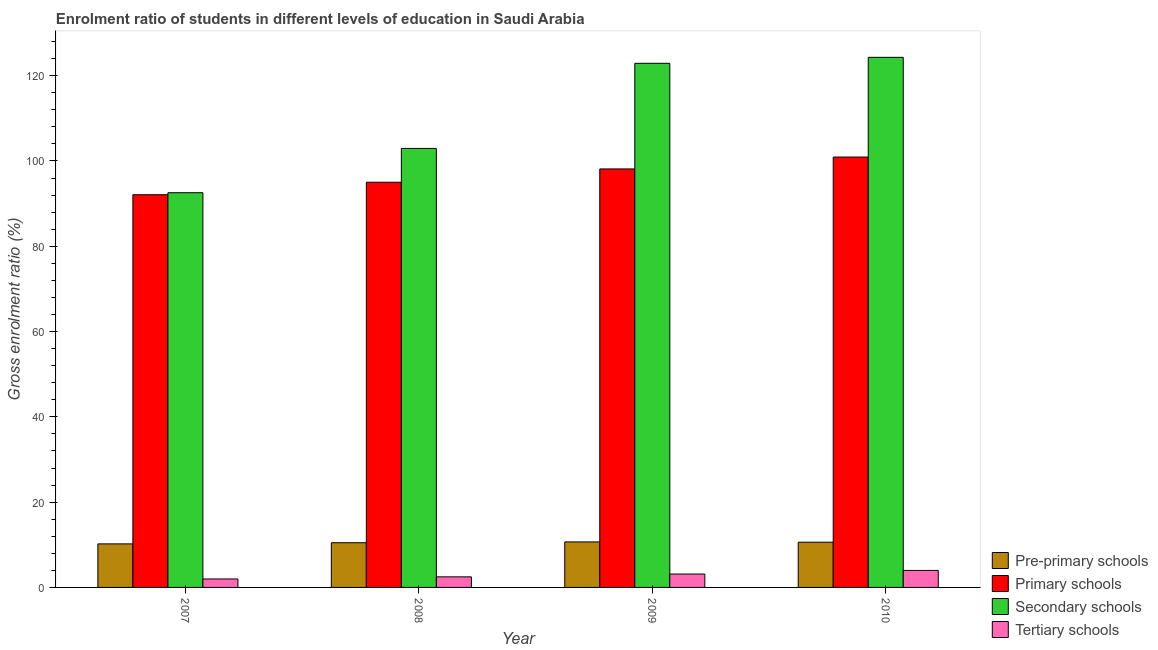How many bars are there on the 1st tick from the left?
Your answer should be very brief. 4. How many bars are there on the 1st tick from the right?
Your response must be concise. 4. What is the label of the 3rd group of bars from the left?
Offer a very short reply. 2009. What is the gross enrolment ratio in primary schools in 2009?
Provide a short and direct response. 98.13. Across all years, what is the maximum gross enrolment ratio in pre-primary schools?
Keep it short and to the point. 10.67. Across all years, what is the minimum gross enrolment ratio in pre-primary schools?
Keep it short and to the point. 10.21. What is the total gross enrolment ratio in secondary schools in the graph?
Your answer should be very brief. 442.69. What is the difference between the gross enrolment ratio in primary schools in 2009 and that in 2010?
Make the answer very short. -2.78. What is the difference between the gross enrolment ratio in pre-primary schools in 2008 and the gross enrolment ratio in primary schools in 2007?
Offer a terse response. 0.27. What is the average gross enrolment ratio in tertiary schools per year?
Keep it short and to the point. 2.9. What is the ratio of the gross enrolment ratio in pre-primary schools in 2007 to that in 2008?
Your answer should be very brief. 0.97. Is the gross enrolment ratio in secondary schools in 2007 less than that in 2010?
Offer a very short reply. Yes. Is the difference between the gross enrolment ratio in primary schools in 2007 and 2009 greater than the difference between the gross enrolment ratio in pre-primary schools in 2007 and 2009?
Your answer should be very brief. No. What is the difference between the highest and the second highest gross enrolment ratio in tertiary schools?
Your answer should be compact. 0.86. What is the difference between the highest and the lowest gross enrolment ratio in tertiary schools?
Your answer should be compact. 2.01. In how many years, is the gross enrolment ratio in tertiary schools greater than the average gross enrolment ratio in tertiary schools taken over all years?
Your answer should be very brief. 2. Is the sum of the gross enrolment ratio in primary schools in 2009 and 2010 greater than the maximum gross enrolment ratio in pre-primary schools across all years?
Make the answer very short. Yes. Is it the case that in every year, the sum of the gross enrolment ratio in primary schools and gross enrolment ratio in secondary schools is greater than the sum of gross enrolment ratio in tertiary schools and gross enrolment ratio in pre-primary schools?
Ensure brevity in your answer.  No. What does the 1st bar from the left in 2007 represents?
Your response must be concise. Pre-primary schools. What does the 1st bar from the right in 2008 represents?
Your answer should be compact. Tertiary schools. Are all the bars in the graph horizontal?
Offer a very short reply. No. What is the difference between two consecutive major ticks on the Y-axis?
Keep it short and to the point. 20. Are the values on the major ticks of Y-axis written in scientific E-notation?
Make the answer very short. No. Does the graph contain grids?
Keep it short and to the point. No. How many legend labels are there?
Your answer should be compact. 4. What is the title of the graph?
Provide a short and direct response. Enrolment ratio of students in different levels of education in Saudi Arabia. What is the label or title of the X-axis?
Provide a short and direct response. Year. What is the label or title of the Y-axis?
Give a very brief answer. Gross enrolment ratio (%). What is the Gross enrolment ratio (%) in Pre-primary schools in 2007?
Your answer should be compact. 10.21. What is the Gross enrolment ratio (%) of Primary schools in 2007?
Offer a terse response. 92.08. What is the Gross enrolment ratio (%) in Secondary schools in 2007?
Keep it short and to the point. 92.55. What is the Gross enrolment ratio (%) of Tertiary schools in 2007?
Give a very brief answer. 1.98. What is the Gross enrolment ratio (%) in Pre-primary schools in 2008?
Offer a terse response. 10.48. What is the Gross enrolment ratio (%) of Primary schools in 2008?
Provide a succinct answer. 95.01. What is the Gross enrolment ratio (%) of Secondary schools in 2008?
Keep it short and to the point. 102.94. What is the Gross enrolment ratio (%) of Tertiary schools in 2008?
Keep it short and to the point. 2.48. What is the Gross enrolment ratio (%) in Pre-primary schools in 2009?
Your answer should be very brief. 10.67. What is the Gross enrolment ratio (%) of Primary schools in 2009?
Give a very brief answer. 98.13. What is the Gross enrolment ratio (%) in Secondary schools in 2009?
Offer a very short reply. 122.9. What is the Gross enrolment ratio (%) of Tertiary schools in 2009?
Offer a very short reply. 3.13. What is the Gross enrolment ratio (%) in Pre-primary schools in 2010?
Offer a terse response. 10.61. What is the Gross enrolment ratio (%) in Primary schools in 2010?
Your answer should be very brief. 100.91. What is the Gross enrolment ratio (%) in Secondary schools in 2010?
Your answer should be very brief. 124.3. What is the Gross enrolment ratio (%) in Tertiary schools in 2010?
Your response must be concise. 3.99. Across all years, what is the maximum Gross enrolment ratio (%) of Pre-primary schools?
Your response must be concise. 10.67. Across all years, what is the maximum Gross enrolment ratio (%) in Primary schools?
Ensure brevity in your answer.  100.91. Across all years, what is the maximum Gross enrolment ratio (%) of Secondary schools?
Provide a succinct answer. 124.3. Across all years, what is the maximum Gross enrolment ratio (%) of Tertiary schools?
Give a very brief answer. 3.99. Across all years, what is the minimum Gross enrolment ratio (%) of Pre-primary schools?
Your response must be concise. 10.21. Across all years, what is the minimum Gross enrolment ratio (%) in Primary schools?
Keep it short and to the point. 92.08. Across all years, what is the minimum Gross enrolment ratio (%) in Secondary schools?
Make the answer very short. 92.55. Across all years, what is the minimum Gross enrolment ratio (%) in Tertiary schools?
Make the answer very short. 1.98. What is the total Gross enrolment ratio (%) in Pre-primary schools in the graph?
Provide a short and direct response. 41.97. What is the total Gross enrolment ratio (%) of Primary schools in the graph?
Give a very brief answer. 386.13. What is the total Gross enrolment ratio (%) of Secondary schools in the graph?
Make the answer very short. 442.69. What is the total Gross enrolment ratio (%) of Tertiary schools in the graph?
Give a very brief answer. 11.59. What is the difference between the Gross enrolment ratio (%) in Pre-primary schools in 2007 and that in 2008?
Give a very brief answer. -0.27. What is the difference between the Gross enrolment ratio (%) of Primary schools in 2007 and that in 2008?
Your response must be concise. -2.93. What is the difference between the Gross enrolment ratio (%) in Secondary schools in 2007 and that in 2008?
Your response must be concise. -10.39. What is the difference between the Gross enrolment ratio (%) in Tertiary schools in 2007 and that in 2008?
Your response must be concise. -0.49. What is the difference between the Gross enrolment ratio (%) of Pre-primary schools in 2007 and that in 2009?
Provide a succinct answer. -0.46. What is the difference between the Gross enrolment ratio (%) of Primary schools in 2007 and that in 2009?
Offer a terse response. -6.05. What is the difference between the Gross enrolment ratio (%) in Secondary schools in 2007 and that in 2009?
Make the answer very short. -30.35. What is the difference between the Gross enrolment ratio (%) in Tertiary schools in 2007 and that in 2009?
Your answer should be compact. -1.15. What is the difference between the Gross enrolment ratio (%) in Pre-primary schools in 2007 and that in 2010?
Keep it short and to the point. -0.4. What is the difference between the Gross enrolment ratio (%) of Primary schools in 2007 and that in 2010?
Offer a very short reply. -8.83. What is the difference between the Gross enrolment ratio (%) in Secondary schools in 2007 and that in 2010?
Offer a terse response. -31.75. What is the difference between the Gross enrolment ratio (%) in Tertiary schools in 2007 and that in 2010?
Make the answer very short. -2.01. What is the difference between the Gross enrolment ratio (%) in Pre-primary schools in 2008 and that in 2009?
Your answer should be very brief. -0.19. What is the difference between the Gross enrolment ratio (%) in Primary schools in 2008 and that in 2009?
Your answer should be compact. -3.12. What is the difference between the Gross enrolment ratio (%) in Secondary schools in 2008 and that in 2009?
Your answer should be compact. -19.96. What is the difference between the Gross enrolment ratio (%) in Tertiary schools in 2008 and that in 2009?
Offer a very short reply. -0.66. What is the difference between the Gross enrolment ratio (%) of Pre-primary schools in 2008 and that in 2010?
Provide a succinct answer. -0.12. What is the difference between the Gross enrolment ratio (%) in Primary schools in 2008 and that in 2010?
Make the answer very short. -5.91. What is the difference between the Gross enrolment ratio (%) of Secondary schools in 2008 and that in 2010?
Your answer should be compact. -21.36. What is the difference between the Gross enrolment ratio (%) of Tertiary schools in 2008 and that in 2010?
Your answer should be compact. -1.51. What is the difference between the Gross enrolment ratio (%) of Pre-primary schools in 2009 and that in 2010?
Offer a very short reply. 0.07. What is the difference between the Gross enrolment ratio (%) of Primary schools in 2009 and that in 2010?
Keep it short and to the point. -2.78. What is the difference between the Gross enrolment ratio (%) in Secondary schools in 2009 and that in 2010?
Make the answer very short. -1.4. What is the difference between the Gross enrolment ratio (%) in Tertiary schools in 2009 and that in 2010?
Make the answer very short. -0.86. What is the difference between the Gross enrolment ratio (%) of Pre-primary schools in 2007 and the Gross enrolment ratio (%) of Primary schools in 2008?
Provide a succinct answer. -84.8. What is the difference between the Gross enrolment ratio (%) of Pre-primary schools in 2007 and the Gross enrolment ratio (%) of Secondary schools in 2008?
Offer a terse response. -92.73. What is the difference between the Gross enrolment ratio (%) of Pre-primary schools in 2007 and the Gross enrolment ratio (%) of Tertiary schools in 2008?
Keep it short and to the point. 7.73. What is the difference between the Gross enrolment ratio (%) of Primary schools in 2007 and the Gross enrolment ratio (%) of Secondary schools in 2008?
Provide a short and direct response. -10.86. What is the difference between the Gross enrolment ratio (%) in Primary schools in 2007 and the Gross enrolment ratio (%) in Tertiary schools in 2008?
Your answer should be compact. 89.6. What is the difference between the Gross enrolment ratio (%) of Secondary schools in 2007 and the Gross enrolment ratio (%) of Tertiary schools in 2008?
Make the answer very short. 90.07. What is the difference between the Gross enrolment ratio (%) in Pre-primary schools in 2007 and the Gross enrolment ratio (%) in Primary schools in 2009?
Give a very brief answer. -87.92. What is the difference between the Gross enrolment ratio (%) of Pre-primary schools in 2007 and the Gross enrolment ratio (%) of Secondary schools in 2009?
Provide a short and direct response. -112.69. What is the difference between the Gross enrolment ratio (%) of Pre-primary schools in 2007 and the Gross enrolment ratio (%) of Tertiary schools in 2009?
Provide a succinct answer. 7.08. What is the difference between the Gross enrolment ratio (%) in Primary schools in 2007 and the Gross enrolment ratio (%) in Secondary schools in 2009?
Make the answer very short. -30.82. What is the difference between the Gross enrolment ratio (%) of Primary schools in 2007 and the Gross enrolment ratio (%) of Tertiary schools in 2009?
Give a very brief answer. 88.95. What is the difference between the Gross enrolment ratio (%) in Secondary schools in 2007 and the Gross enrolment ratio (%) in Tertiary schools in 2009?
Keep it short and to the point. 89.42. What is the difference between the Gross enrolment ratio (%) in Pre-primary schools in 2007 and the Gross enrolment ratio (%) in Primary schools in 2010?
Ensure brevity in your answer.  -90.71. What is the difference between the Gross enrolment ratio (%) in Pre-primary schools in 2007 and the Gross enrolment ratio (%) in Secondary schools in 2010?
Make the answer very short. -114.09. What is the difference between the Gross enrolment ratio (%) in Pre-primary schools in 2007 and the Gross enrolment ratio (%) in Tertiary schools in 2010?
Ensure brevity in your answer.  6.22. What is the difference between the Gross enrolment ratio (%) in Primary schools in 2007 and the Gross enrolment ratio (%) in Secondary schools in 2010?
Your answer should be very brief. -32.22. What is the difference between the Gross enrolment ratio (%) in Primary schools in 2007 and the Gross enrolment ratio (%) in Tertiary schools in 2010?
Ensure brevity in your answer.  88.09. What is the difference between the Gross enrolment ratio (%) of Secondary schools in 2007 and the Gross enrolment ratio (%) of Tertiary schools in 2010?
Provide a succinct answer. 88.56. What is the difference between the Gross enrolment ratio (%) in Pre-primary schools in 2008 and the Gross enrolment ratio (%) in Primary schools in 2009?
Provide a short and direct response. -87.65. What is the difference between the Gross enrolment ratio (%) in Pre-primary schools in 2008 and the Gross enrolment ratio (%) in Secondary schools in 2009?
Your response must be concise. -112.42. What is the difference between the Gross enrolment ratio (%) in Pre-primary schools in 2008 and the Gross enrolment ratio (%) in Tertiary schools in 2009?
Offer a terse response. 7.35. What is the difference between the Gross enrolment ratio (%) in Primary schools in 2008 and the Gross enrolment ratio (%) in Secondary schools in 2009?
Ensure brevity in your answer.  -27.89. What is the difference between the Gross enrolment ratio (%) in Primary schools in 2008 and the Gross enrolment ratio (%) in Tertiary schools in 2009?
Your response must be concise. 91.87. What is the difference between the Gross enrolment ratio (%) of Secondary schools in 2008 and the Gross enrolment ratio (%) of Tertiary schools in 2009?
Make the answer very short. 99.81. What is the difference between the Gross enrolment ratio (%) in Pre-primary schools in 2008 and the Gross enrolment ratio (%) in Primary schools in 2010?
Provide a short and direct response. -90.43. What is the difference between the Gross enrolment ratio (%) in Pre-primary schools in 2008 and the Gross enrolment ratio (%) in Secondary schools in 2010?
Your answer should be very brief. -113.82. What is the difference between the Gross enrolment ratio (%) in Pre-primary schools in 2008 and the Gross enrolment ratio (%) in Tertiary schools in 2010?
Your response must be concise. 6.49. What is the difference between the Gross enrolment ratio (%) in Primary schools in 2008 and the Gross enrolment ratio (%) in Secondary schools in 2010?
Offer a very short reply. -29.29. What is the difference between the Gross enrolment ratio (%) of Primary schools in 2008 and the Gross enrolment ratio (%) of Tertiary schools in 2010?
Your answer should be very brief. 91.02. What is the difference between the Gross enrolment ratio (%) of Secondary schools in 2008 and the Gross enrolment ratio (%) of Tertiary schools in 2010?
Keep it short and to the point. 98.95. What is the difference between the Gross enrolment ratio (%) of Pre-primary schools in 2009 and the Gross enrolment ratio (%) of Primary schools in 2010?
Make the answer very short. -90.24. What is the difference between the Gross enrolment ratio (%) of Pre-primary schools in 2009 and the Gross enrolment ratio (%) of Secondary schools in 2010?
Make the answer very short. -113.63. What is the difference between the Gross enrolment ratio (%) of Pre-primary schools in 2009 and the Gross enrolment ratio (%) of Tertiary schools in 2010?
Keep it short and to the point. 6.68. What is the difference between the Gross enrolment ratio (%) in Primary schools in 2009 and the Gross enrolment ratio (%) in Secondary schools in 2010?
Offer a terse response. -26.17. What is the difference between the Gross enrolment ratio (%) in Primary schools in 2009 and the Gross enrolment ratio (%) in Tertiary schools in 2010?
Keep it short and to the point. 94.14. What is the difference between the Gross enrolment ratio (%) in Secondary schools in 2009 and the Gross enrolment ratio (%) in Tertiary schools in 2010?
Keep it short and to the point. 118.91. What is the average Gross enrolment ratio (%) in Pre-primary schools per year?
Offer a very short reply. 10.49. What is the average Gross enrolment ratio (%) in Primary schools per year?
Give a very brief answer. 96.53. What is the average Gross enrolment ratio (%) of Secondary schools per year?
Your answer should be very brief. 110.67. What is the average Gross enrolment ratio (%) in Tertiary schools per year?
Provide a succinct answer. 2.9. In the year 2007, what is the difference between the Gross enrolment ratio (%) in Pre-primary schools and Gross enrolment ratio (%) in Primary schools?
Your response must be concise. -81.87. In the year 2007, what is the difference between the Gross enrolment ratio (%) in Pre-primary schools and Gross enrolment ratio (%) in Secondary schools?
Offer a very short reply. -82.34. In the year 2007, what is the difference between the Gross enrolment ratio (%) of Pre-primary schools and Gross enrolment ratio (%) of Tertiary schools?
Your response must be concise. 8.23. In the year 2007, what is the difference between the Gross enrolment ratio (%) of Primary schools and Gross enrolment ratio (%) of Secondary schools?
Your answer should be compact. -0.47. In the year 2007, what is the difference between the Gross enrolment ratio (%) in Primary schools and Gross enrolment ratio (%) in Tertiary schools?
Your answer should be compact. 90.1. In the year 2007, what is the difference between the Gross enrolment ratio (%) in Secondary schools and Gross enrolment ratio (%) in Tertiary schools?
Your response must be concise. 90.57. In the year 2008, what is the difference between the Gross enrolment ratio (%) in Pre-primary schools and Gross enrolment ratio (%) in Primary schools?
Your answer should be very brief. -84.53. In the year 2008, what is the difference between the Gross enrolment ratio (%) of Pre-primary schools and Gross enrolment ratio (%) of Secondary schools?
Your answer should be very brief. -92.46. In the year 2008, what is the difference between the Gross enrolment ratio (%) in Pre-primary schools and Gross enrolment ratio (%) in Tertiary schools?
Keep it short and to the point. 8. In the year 2008, what is the difference between the Gross enrolment ratio (%) in Primary schools and Gross enrolment ratio (%) in Secondary schools?
Make the answer very short. -7.93. In the year 2008, what is the difference between the Gross enrolment ratio (%) of Primary schools and Gross enrolment ratio (%) of Tertiary schools?
Your answer should be very brief. 92.53. In the year 2008, what is the difference between the Gross enrolment ratio (%) in Secondary schools and Gross enrolment ratio (%) in Tertiary schools?
Make the answer very short. 100.46. In the year 2009, what is the difference between the Gross enrolment ratio (%) in Pre-primary schools and Gross enrolment ratio (%) in Primary schools?
Your answer should be compact. -87.46. In the year 2009, what is the difference between the Gross enrolment ratio (%) in Pre-primary schools and Gross enrolment ratio (%) in Secondary schools?
Make the answer very short. -112.23. In the year 2009, what is the difference between the Gross enrolment ratio (%) of Pre-primary schools and Gross enrolment ratio (%) of Tertiary schools?
Offer a terse response. 7.54. In the year 2009, what is the difference between the Gross enrolment ratio (%) in Primary schools and Gross enrolment ratio (%) in Secondary schools?
Keep it short and to the point. -24.77. In the year 2009, what is the difference between the Gross enrolment ratio (%) of Primary schools and Gross enrolment ratio (%) of Tertiary schools?
Provide a short and direct response. 95. In the year 2009, what is the difference between the Gross enrolment ratio (%) in Secondary schools and Gross enrolment ratio (%) in Tertiary schools?
Provide a short and direct response. 119.77. In the year 2010, what is the difference between the Gross enrolment ratio (%) of Pre-primary schools and Gross enrolment ratio (%) of Primary schools?
Offer a terse response. -90.31. In the year 2010, what is the difference between the Gross enrolment ratio (%) in Pre-primary schools and Gross enrolment ratio (%) in Secondary schools?
Keep it short and to the point. -113.69. In the year 2010, what is the difference between the Gross enrolment ratio (%) of Pre-primary schools and Gross enrolment ratio (%) of Tertiary schools?
Give a very brief answer. 6.62. In the year 2010, what is the difference between the Gross enrolment ratio (%) in Primary schools and Gross enrolment ratio (%) in Secondary schools?
Offer a terse response. -23.39. In the year 2010, what is the difference between the Gross enrolment ratio (%) in Primary schools and Gross enrolment ratio (%) in Tertiary schools?
Give a very brief answer. 96.92. In the year 2010, what is the difference between the Gross enrolment ratio (%) of Secondary schools and Gross enrolment ratio (%) of Tertiary schools?
Your answer should be very brief. 120.31. What is the ratio of the Gross enrolment ratio (%) of Pre-primary schools in 2007 to that in 2008?
Your answer should be compact. 0.97. What is the ratio of the Gross enrolment ratio (%) in Primary schools in 2007 to that in 2008?
Make the answer very short. 0.97. What is the ratio of the Gross enrolment ratio (%) of Secondary schools in 2007 to that in 2008?
Provide a short and direct response. 0.9. What is the ratio of the Gross enrolment ratio (%) in Tertiary schools in 2007 to that in 2008?
Make the answer very short. 0.8. What is the ratio of the Gross enrolment ratio (%) in Pre-primary schools in 2007 to that in 2009?
Ensure brevity in your answer.  0.96. What is the ratio of the Gross enrolment ratio (%) of Primary schools in 2007 to that in 2009?
Offer a terse response. 0.94. What is the ratio of the Gross enrolment ratio (%) in Secondary schools in 2007 to that in 2009?
Your answer should be very brief. 0.75. What is the ratio of the Gross enrolment ratio (%) in Tertiary schools in 2007 to that in 2009?
Provide a succinct answer. 0.63. What is the ratio of the Gross enrolment ratio (%) of Pre-primary schools in 2007 to that in 2010?
Keep it short and to the point. 0.96. What is the ratio of the Gross enrolment ratio (%) in Primary schools in 2007 to that in 2010?
Ensure brevity in your answer.  0.91. What is the ratio of the Gross enrolment ratio (%) of Secondary schools in 2007 to that in 2010?
Provide a succinct answer. 0.74. What is the ratio of the Gross enrolment ratio (%) in Tertiary schools in 2007 to that in 2010?
Offer a very short reply. 0.5. What is the ratio of the Gross enrolment ratio (%) of Pre-primary schools in 2008 to that in 2009?
Ensure brevity in your answer.  0.98. What is the ratio of the Gross enrolment ratio (%) of Primary schools in 2008 to that in 2009?
Your answer should be compact. 0.97. What is the ratio of the Gross enrolment ratio (%) of Secondary schools in 2008 to that in 2009?
Make the answer very short. 0.84. What is the ratio of the Gross enrolment ratio (%) in Tertiary schools in 2008 to that in 2009?
Your response must be concise. 0.79. What is the ratio of the Gross enrolment ratio (%) in Pre-primary schools in 2008 to that in 2010?
Your answer should be very brief. 0.99. What is the ratio of the Gross enrolment ratio (%) of Primary schools in 2008 to that in 2010?
Make the answer very short. 0.94. What is the ratio of the Gross enrolment ratio (%) of Secondary schools in 2008 to that in 2010?
Offer a terse response. 0.83. What is the ratio of the Gross enrolment ratio (%) of Tertiary schools in 2008 to that in 2010?
Keep it short and to the point. 0.62. What is the ratio of the Gross enrolment ratio (%) of Pre-primary schools in 2009 to that in 2010?
Offer a very short reply. 1.01. What is the ratio of the Gross enrolment ratio (%) of Primary schools in 2009 to that in 2010?
Your answer should be compact. 0.97. What is the ratio of the Gross enrolment ratio (%) of Secondary schools in 2009 to that in 2010?
Your answer should be compact. 0.99. What is the ratio of the Gross enrolment ratio (%) of Tertiary schools in 2009 to that in 2010?
Your answer should be compact. 0.79. What is the difference between the highest and the second highest Gross enrolment ratio (%) of Pre-primary schools?
Provide a succinct answer. 0.07. What is the difference between the highest and the second highest Gross enrolment ratio (%) of Primary schools?
Your answer should be very brief. 2.78. What is the difference between the highest and the second highest Gross enrolment ratio (%) of Secondary schools?
Ensure brevity in your answer.  1.4. What is the difference between the highest and the second highest Gross enrolment ratio (%) in Tertiary schools?
Keep it short and to the point. 0.86. What is the difference between the highest and the lowest Gross enrolment ratio (%) in Pre-primary schools?
Your answer should be compact. 0.46. What is the difference between the highest and the lowest Gross enrolment ratio (%) in Primary schools?
Your answer should be very brief. 8.83. What is the difference between the highest and the lowest Gross enrolment ratio (%) in Secondary schools?
Make the answer very short. 31.75. What is the difference between the highest and the lowest Gross enrolment ratio (%) of Tertiary schools?
Make the answer very short. 2.01. 